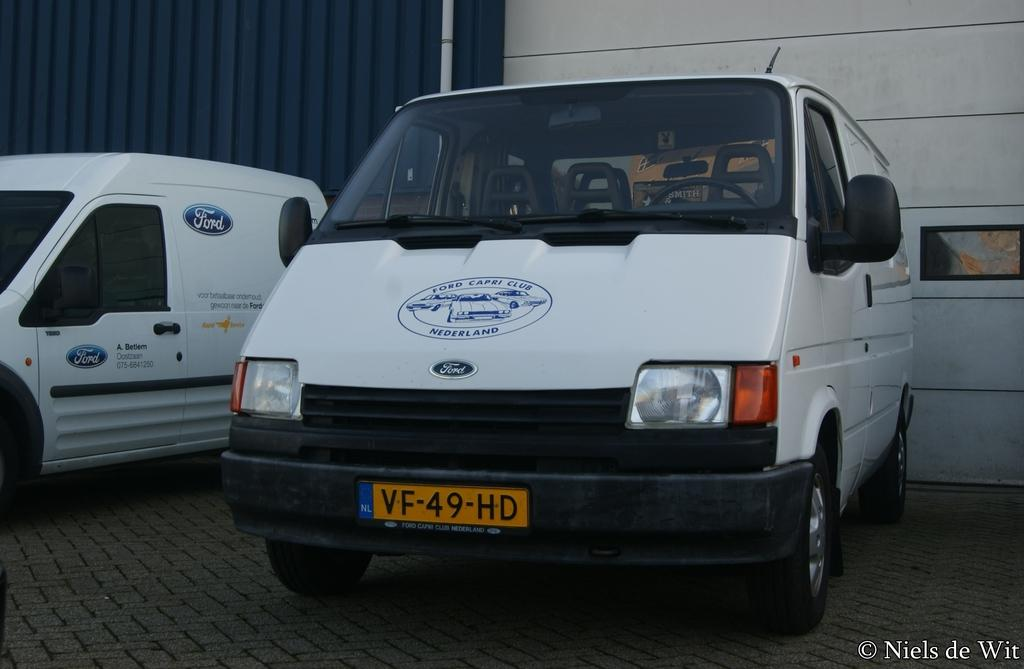<image>
Share a concise interpretation of the image provided. A white Ford van has a Ford Capri Club Nederland logo on its hood. 